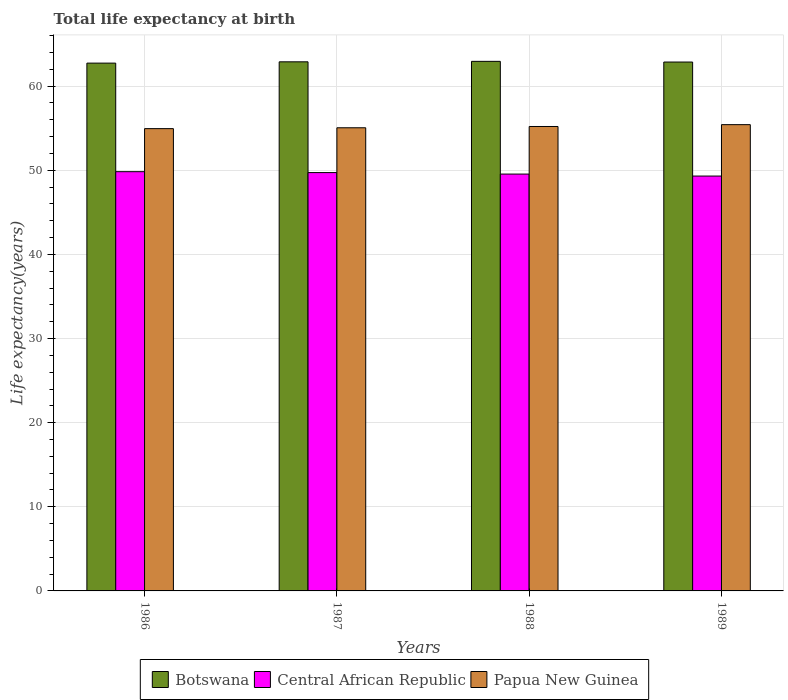How many different coloured bars are there?
Your answer should be compact. 3. How many groups of bars are there?
Make the answer very short. 4. Are the number of bars per tick equal to the number of legend labels?
Provide a short and direct response. Yes. Are the number of bars on each tick of the X-axis equal?
Make the answer very short. Yes. What is the life expectancy at birth in in Papua New Guinea in 1989?
Offer a very short reply. 55.42. Across all years, what is the maximum life expectancy at birth in in Botswana?
Your answer should be compact. 62.95. Across all years, what is the minimum life expectancy at birth in in Papua New Guinea?
Your response must be concise. 54.95. In which year was the life expectancy at birth in in Central African Republic minimum?
Give a very brief answer. 1989. What is the total life expectancy at birth in in Botswana in the graph?
Offer a terse response. 251.43. What is the difference between the life expectancy at birth in in Central African Republic in 1987 and that in 1989?
Provide a short and direct response. 0.41. What is the difference between the life expectancy at birth in in Central African Republic in 1988 and the life expectancy at birth in in Papua New Guinea in 1987?
Offer a very short reply. -5.5. What is the average life expectancy at birth in in Botswana per year?
Provide a short and direct response. 62.86. In the year 1989, what is the difference between the life expectancy at birth in in Central African Republic and life expectancy at birth in in Botswana?
Keep it short and to the point. -13.55. What is the ratio of the life expectancy at birth in in Central African Republic in 1986 to that in 1987?
Provide a succinct answer. 1. What is the difference between the highest and the second highest life expectancy at birth in in Botswana?
Your answer should be very brief. 0.06. What is the difference between the highest and the lowest life expectancy at birth in in Botswana?
Make the answer very short. 0.21. In how many years, is the life expectancy at birth in in Papua New Guinea greater than the average life expectancy at birth in in Papua New Guinea taken over all years?
Ensure brevity in your answer.  2. What does the 1st bar from the left in 1989 represents?
Ensure brevity in your answer.  Botswana. What does the 3rd bar from the right in 1988 represents?
Give a very brief answer. Botswana. Is it the case that in every year, the sum of the life expectancy at birth in in Botswana and life expectancy at birth in in Papua New Guinea is greater than the life expectancy at birth in in Central African Republic?
Make the answer very short. Yes. How many bars are there?
Ensure brevity in your answer.  12. Are all the bars in the graph horizontal?
Provide a succinct answer. No. What is the difference between two consecutive major ticks on the Y-axis?
Offer a terse response. 10. Does the graph contain any zero values?
Offer a very short reply. No. Does the graph contain grids?
Ensure brevity in your answer.  Yes. Where does the legend appear in the graph?
Offer a terse response. Bottom center. What is the title of the graph?
Provide a succinct answer. Total life expectancy at birth. What is the label or title of the Y-axis?
Your answer should be compact. Life expectancy(years). What is the Life expectancy(years) of Botswana in 1986?
Your answer should be compact. 62.74. What is the Life expectancy(years) of Central African Republic in 1986?
Your answer should be compact. 49.83. What is the Life expectancy(years) of Papua New Guinea in 1986?
Your answer should be compact. 54.95. What is the Life expectancy(years) in Botswana in 1987?
Provide a short and direct response. 62.89. What is the Life expectancy(years) in Central African Republic in 1987?
Make the answer very short. 49.72. What is the Life expectancy(years) of Papua New Guinea in 1987?
Your answer should be very brief. 55.05. What is the Life expectancy(years) in Botswana in 1988?
Your response must be concise. 62.95. What is the Life expectancy(years) of Central African Republic in 1988?
Offer a terse response. 49.55. What is the Life expectancy(years) in Papua New Guinea in 1988?
Provide a short and direct response. 55.2. What is the Life expectancy(years) in Botswana in 1989?
Give a very brief answer. 62.86. What is the Life expectancy(years) in Central African Republic in 1989?
Your response must be concise. 49.31. What is the Life expectancy(years) in Papua New Guinea in 1989?
Offer a very short reply. 55.42. Across all years, what is the maximum Life expectancy(years) in Botswana?
Provide a short and direct response. 62.95. Across all years, what is the maximum Life expectancy(years) in Central African Republic?
Your answer should be compact. 49.83. Across all years, what is the maximum Life expectancy(years) of Papua New Guinea?
Your answer should be compact. 55.42. Across all years, what is the minimum Life expectancy(years) in Botswana?
Provide a succinct answer. 62.74. Across all years, what is the minimum Life expectancy(years) in Central African Republic?
Keep it short and to the point. 49.31. Across all years, what is the minimum Life expectancy(years) in Papua New Guinea?
Provide a short and direct response. 54.95. What is the total Life expectancy(years) in Botswana in the graph?
Ensure brevity in your answer.  251.43. What is the total Life expectancy(years) in Central African Republic in the graph?
Provide a short and direct response. 198.42. What is the total Life expectancy(years) of Papua New Guinea in the graph?
Keep it short and to the point. 220.63. What is the difference between the Life expectancy(years) of Botswana in 1986 and that in 1987?
Make the answer very short. -0.15. What is the difference between the Life expectancy(years) in Central African Republic in 1986 and that in 1987?
Make the answer very short. 0.11. What is the difference between the Life expectancy(years) in Papua New Guinea in 1986 and that in 1987?
Offer a very short reply. -0.1. What is the difference between the Life expectancy(years) of Botswana in 1986 and that in 1988?
Give a very brief answer. -0.21. What is the difference between the Life expectancy(years) in Central African Republic in 1986 and that in 1988?
Your answer should be very brief. 0.28. What is the difference between the Life expectancy(years) of Papua New Guinea in 1986 and that in 1988?
Give a very brief answer. -0.25. What is the difference between the Life expectancy(years) in Botswana in 1986 and that in 1989?
Your answer should be very brief. -0.13. What is the difference between the Life expectancy(years) in Central African Republic in 1986 and that in 1989?
Offer a terse response. 0.52. What is the difference between the Life expectancy(years) of Papua New Guinea in 1986 and that in 1989?
Your answer should be very brief. -0.47. What is the difference between the Life expectancy(years) of Botswana in 1987 and that in 1988?
Offer a very short reply. -0.06. What is the difference between the Life expectancy(years) in Central African Republic in 1987 and that in 1988?
Make the answer very short. 0.18. What is the difference between the Life expectancy(years) of Papua New Guinea in 1987 and that in 1988?
Ensure brevity in your answer.  -0.15. What is the difference between the Life expectancy(years) in Botswana in 1987 and that in 1989?
Offer a very short reply. 0.03. What is the difference between the Life expectancy(years) of Central African Republic in 1987 and that in 1989?
Make the answer very short. 0.41. What is the difference between the Life expectancy(years) in Papua New Guinea in 1987 and that in 1989?
Ensure brevity in your answer.  -0.37. What is the difference between the Life expectancy(years) in Botswana in 1988 and that in 1989?
Offer a very short reply. 0.08. What is the difference between the Life expectancy(years) in Central African Republic in 1988 and that in 1989?
Your answer should be compact. 0.24. What is the difference between the Life expectancy(years) of Papua New Guinea in 1988 and that in 1989?
Provide a short and direct response. -0.22. What is the difference between the Life expectancy(years) of Botswana in 1986 and the Life expectancy(years) of Central African Republic in 1987?
Provide a succinct answer. 13.01. What is the difference between the Life expectancy(years) in Botswana in 1986 and the Life expectancy(years) in Papua New Guinea in 1987?
Offer a very short reply. 7.68. What is the difference between the Life expectancy(years) of Central African Republic in 1986 and the Life expectancy(years) of Papua New Guinea in 1987?
Provide a short and direct response. -5.22. What is the difference between the Life expectancy(years) of Botswana in 1986 and the Life expectancy(years) of Central African Republic in 1988?
Ensure brevity in your answer.  13.19. What is the difference between the Life expectancy(years) in Botswana in 1986 and the Life expectancy(years) in Papua New Guinea in 1988?
Provide a succinct answer. 7.53. What is the difference between the Life expectancy(years) of Central African Republic in 1986 and the Life expectancy(years) of Papua New Guinea in 1988?
Make the answer very short. -5.37. What is the difference between the Life expectancy(years) of Botswana in 1986 and the Life expectancy(years) of Central African Republic in 1989?
Provide a succinct answer. 13.42. What is the difference between the Life expectancy(years) in Botswana in 1986 and the Life expectancy(years) in Papua New Guinea in 1989?
Provide a succinct answer. 7.31. What is the difference between the Life expectancy(years) in Central African Republic in 1986 and the Life expectancy(years) in Papua New Guinea in 1989?
Offer a very short reply. -5.59. What is the difference between the Life expectancy(years) of Botswana in 1987 and the Life expectancy(years) of Central African Republic in 1988?
Offer a very short reply. 13.34. What is the difference between the Life expectancy(years) in Botswana in 1987 and the Life expectancy(years) in Papua New Guinea in 1988?
Keep it short and to the point. 7.69. What is the difference between the Life expectancy(years) of Central African Republic in 1987 and the Life expectancy(years) of Papua New Guinea in 1988?
Give a very brief answer. -5.48. What is the difference between the Life expectancy(years) in Botswana in 1987 and the Life expectancy(years) in Central African Republic in 1989?
Your response must be concise. 13.58. What is the difference between the Life expectancy(years) in Botswana in 1987 and the Life expectancy(years) in Papua New Guinea in 1989?
Offer a very short reply. 7.47. What is the difference between the Life expectancy(years) of Central African Republic in 1987 and the Life expectancy(years) of Papua New Guinea in 1989?
Make the answer very short. -5.7. What is the difference between the Life expectancy(years) in Botswana in 1988 and the Life expectancy(years) in Central African Republic in 1989?
Keep it short and to the point. 13.63. What is the difference between the Life expectancy(years) in Botswana in 1988 and the Life expectancy(years) in Papua New Guinea in 1989?
Keep it short and to the point. 7.52. What is the difference between the Life expectancy(years) of Central African Republic in 1988 and the Life expectancy(years) of Papua New Guinea in 1989?
Your answer should be compact. -5.87. What is the average Life expectancy(years) in Botswana per year?
Offer a very short reply. 62.86. What is the average Life expectancy(years) in Central African Republic per year?
Offer a very short reply. 49.6. What is the average Life expectancy(years) in Papua New Guinea per year?
Give a very brief answer. 55.16. In the year 1986, what is the difference between the Life expectancy(years) in Botswana and Life expectancy(years) in Central African Republic?
Provide a short and direct response. 12.9. In the year 1986, what is the difference between the Life expectancy(years) in Botswana and Life expectancy(years) in Papua New Guinea?
Offer a very short reply. 7.79. In the year 1986, what is the difference between the Life expectancy(years) in Central African Republic and Life expectancy(years) in Papua New Guinea?
Your response must be concise. -5.12. In the year 1987, what is the difference between the Life expectancy(years) of Botswana and Life expectancy(years) of Central African Republic?
Keep it short and to the point. 13.17. In the year 1987, what is the difference between the Life expectancy(years) of Botswana and Life expectancy(years) of Papua New Guinea?
Your answer should be very brief. 7.84. In the year 1987, what is the difference between the Life expectancy(years) of Central African Republic and Life expectancy(years) of Papua New Guinea?
Provide a succinct answer. -5.33. In the year 1988, what is the difference between the Life expectancy(years) of Botswana and Life expectancy(years) of Central African Republic?
Your response must be concise. 13.4. In the year 1988, what is the difference between the Life expectancy(years) of Botswana and Life expectancy(years) of Papua New Guinea?
Your answer should be very brief. 7.74. In the year 1988, what is the difference between the Life expectancy(years) in Central African Republic and Life expectancy(years) in Papua New Guinea?
Make the answer very short. -5.65. In the year 1989, what is the difference between the Life expectancy(years) in Botswana and Life expectancy(years) in Central African Republic?
Offer a very short reply. 13.55. In the year 1989, what is the difference between the Life expectancy(years) in Botswana and Life expectancy(years) in Papua New Guinea?
Provide a short and direct response. 7.44. In the year 1989, what is the difference between the Life expectancy(years) in Central African Republic and Life expectancy(years) in Papua New Guinea?
Offer a terse response. -6.11. What is the ratio of the Life expectancy(years) of Botswana in 1986 to that in 1988?
Offer a very short reply. 1. What is the ratio of the Life expectancy(years) in Central African Republic in 1986 to that in 1988?
Offer a very short reply. 1.01. What is the ratio of the Life expectancy(years) of Papua New Guinea in 1986 to that in 1988?
Give a very brief answer. 1. What is the ratio of the Life expectancy(years) in Botswana in 1986 to that in 1989?
Provide a succinct answer. 1. What is the ratio of the Life expectancy(years) in Central African Republic in 1986 to that in 1989?
Make the answer very short. 1.01. What is the ratio of the Life expectancy(years) of Papua New Guinea in 1986 to that in 1989?
Ensure brevity in your answer.  0.99. What is the ratio of the Life expectancy(years) of Central African Republic in 1987 to that in 1988?
Your response must be concise. 1. What is the ratio of the Life expectancy(years) of Botswana in 1987 to that in 1989?
Your response must be concise. 1. What is the ratio of the Life expectancy(years) in Central African Republic in 1987 to that in 1989?
Your response must be concise. 1.01. What is the ratio of the Life expectancy(years) of Botswana in 1988 to that in 1989?
Keep it short and to the point. 1. What is the ratio of the Life expectancy(years) of Central African Republic in 1988 to that in 1989?
Make the answer very short. 1. What is the difference between the highest and the second highest Life expectancy(years) of Botswana?
Provide a succinct answer. 0.06. What is the difference between the highest and the second highest Life expectancy(years) in Central African Republic?
Offer a terse response. 0.11. What is the difference between the highest and the second highest Life expectancy(years) in Papua New Guinea?
Offer a terse response. 0.22. What is the difference between the highest and the lowest Life expectancy(years) in Botswana?
Make the answer very short. 0.21. What is the difference between the highest and the lowest Life expectancy(years) of Central African Republic?
Provide a short and direct response. 0.52. What is the difference between the highest and the lowest Life expectancy(years) of Papua New Guinea?
Offer a terse response. 0.47. 